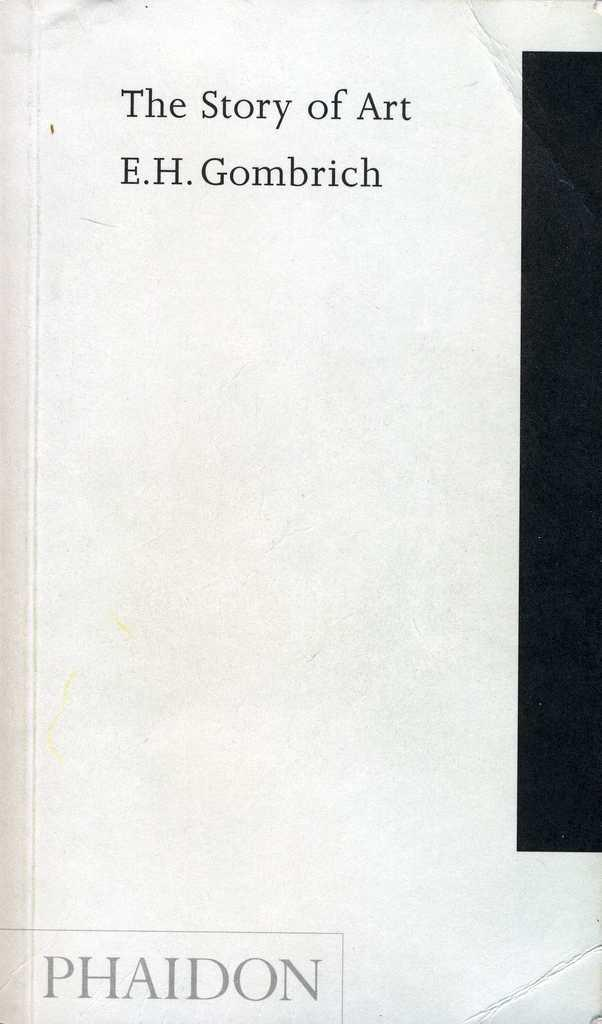Provide a one-sentence caption for the provided image. A book by E.H Gombrich and the title is The Story of Art. 